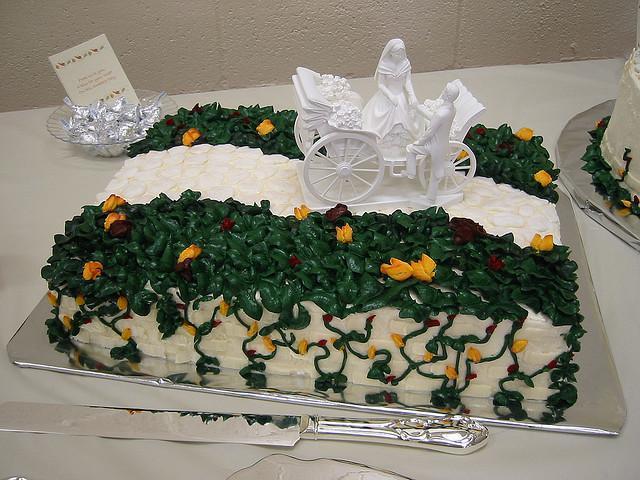How many cakes can be seen?
Give a very brief answer. 2. How many knives can you see?
Give a very brief answer. 1. 